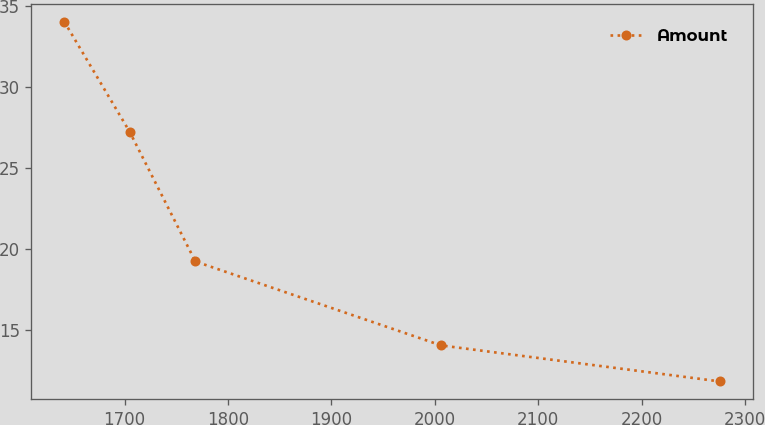Convert chart. <chart><loc_0><loc_0><loc_500><loc_500><line_chart><ecel><fcel>Amount<nl><fcel>1641.7<fcel>34.04<nl><fcel>1705.11<fcel>27.23<nl><fcel>1768.52<fcel>19.25<nl><fcel>2006.28<fcel>14.07<nl><fcel>2275.83<fcel>11.85<nl></chart> 